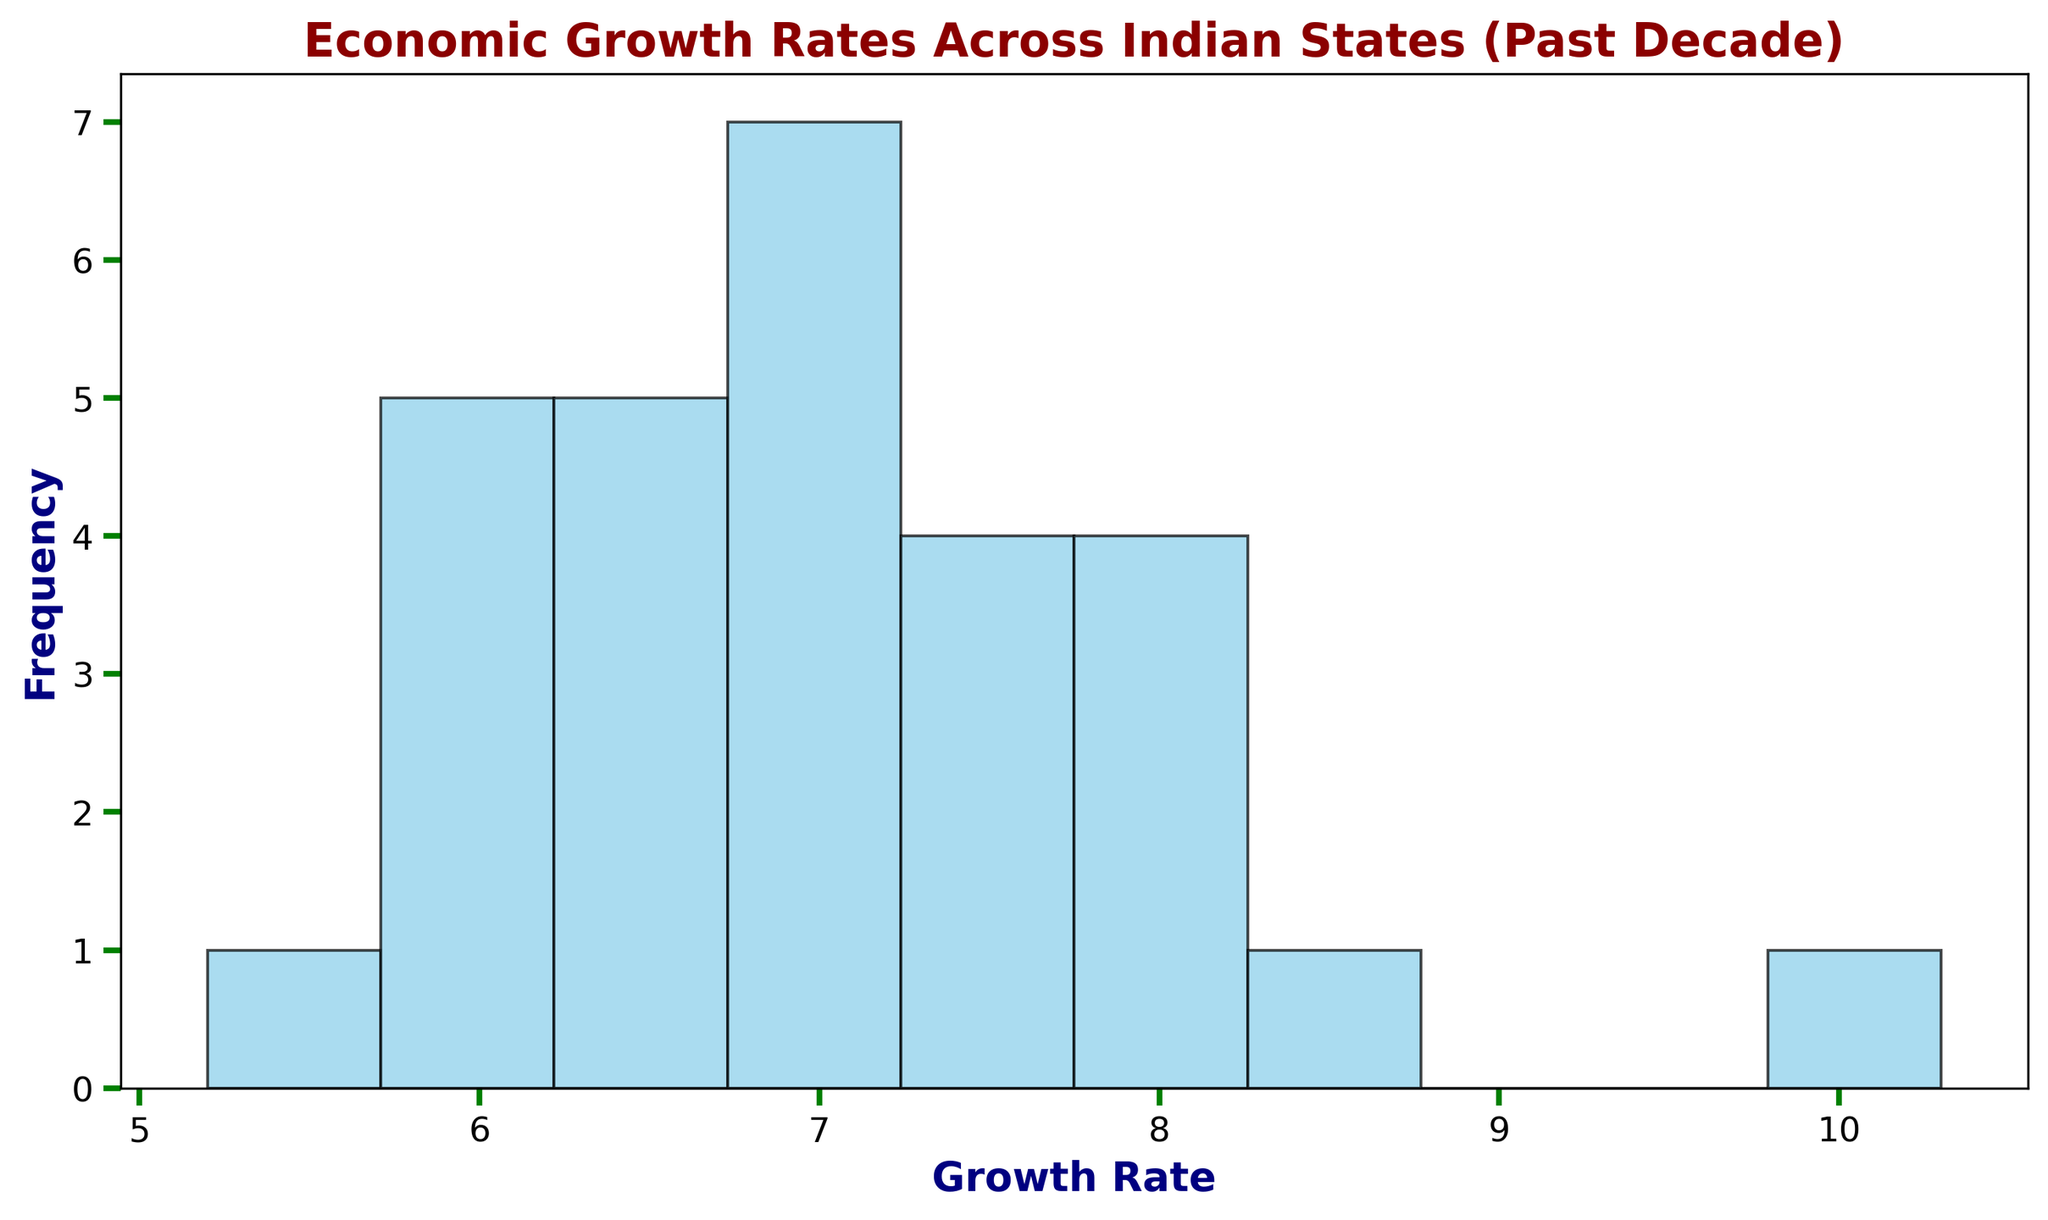What's the most common range of growth rates as seen in the histogram? The histogram would show bars of different heights representing the frequency of states falling into specific growth rate ranges. Identify the tallest bar; that range represents the most common growth rates.
Answer: 6-7% What is the approximate width of a bin in the histogram? The entire range of growth rates spans from around 5 to 10, and the histogram uses 10 bins. Therefore, the width of each bin is the total range divided by the number of bins: (10 - 5) / 10 = 0.5.
Answer: 0.5% How many states have a growth rate between 7% and 8%? Identify the bar that covers the 7% to 8% range and count its height, which represents the number of states in that range.
Answer: 5 Which state is the outlier with the highest growth rate, as indicated by the histogram? Scan the histogram for the rightmost bar representing the highest growth rate, then refer to the corresponding data. Bihar has the highest growth rate of 10.3%.
Answer: Bihar How does the frequency of states with growth rates between 5% to 6% compare to those with growth rates between 8% to 9%? Count the heights of the bars for the ranges 5% to 6% and 8% to 9%. The histogram would show that the latter range has fewer states compared to the former.
Answer: 5-6% range has more states What is the combined frequency of states with growth rates below 6%? Identify and add the frequencies of bars falling below the 6% growth rate mark on the histogram to get the total count.
Answer: 4 Estimate the range containing the median growth rate. Since there are 28 states, the median would fall in the 14th and 15th positions when ordered numerically. Identify the bar containing these central two states on the histogram.
Answer: 6-7% What is the frequency of states with growth rates higher than 8%? Sum the heights of the bars corresponding to the ranges above 8% on the histogram.
Answer: 4 Which growth rate interval appears most frequently and why is it significant? The histogram's highest bar marks the most frequent interval, indicating many states have a growth rate close to this range, showcasing economic similarities.
Answer: 6-7% How many states have growth rates below the overall average? Calculate the average growth rate from the data, then use the histogram to count bars representing states below this average rate. With 28 states, add their growth rates to find the average and count those below it.
Answer: Approximately 14 